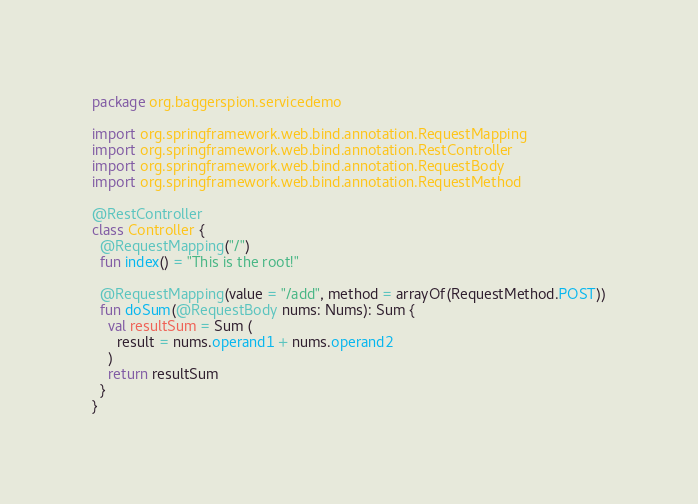Convert code to text. <code><loc_0><loc_0><loc_500><loc_500><_Kotlin_>package org.baggerspion.servicedemo

import org.springframework.web.bind.annotation.RequestMapping
import org.springframework.web.bind.annotation.RestController
import org.springframework.web.bind.annotation.RequestBody
import org.springframework.web.bind.annotation.RequestMethod

@RestController
class Controller {
  @RequestMapping("/")
  fun index() = "This is the root!"

  @RequestMapping(value = "/add", method = arrayOf(RequestMethod.POST))
  fun doSum(@RequestBody nums: Nums): Sum {
    val resultSum = Sum (
      result = nums.operand1 + nums.operand2
    )
    return resultSum
  }
}
</code> 